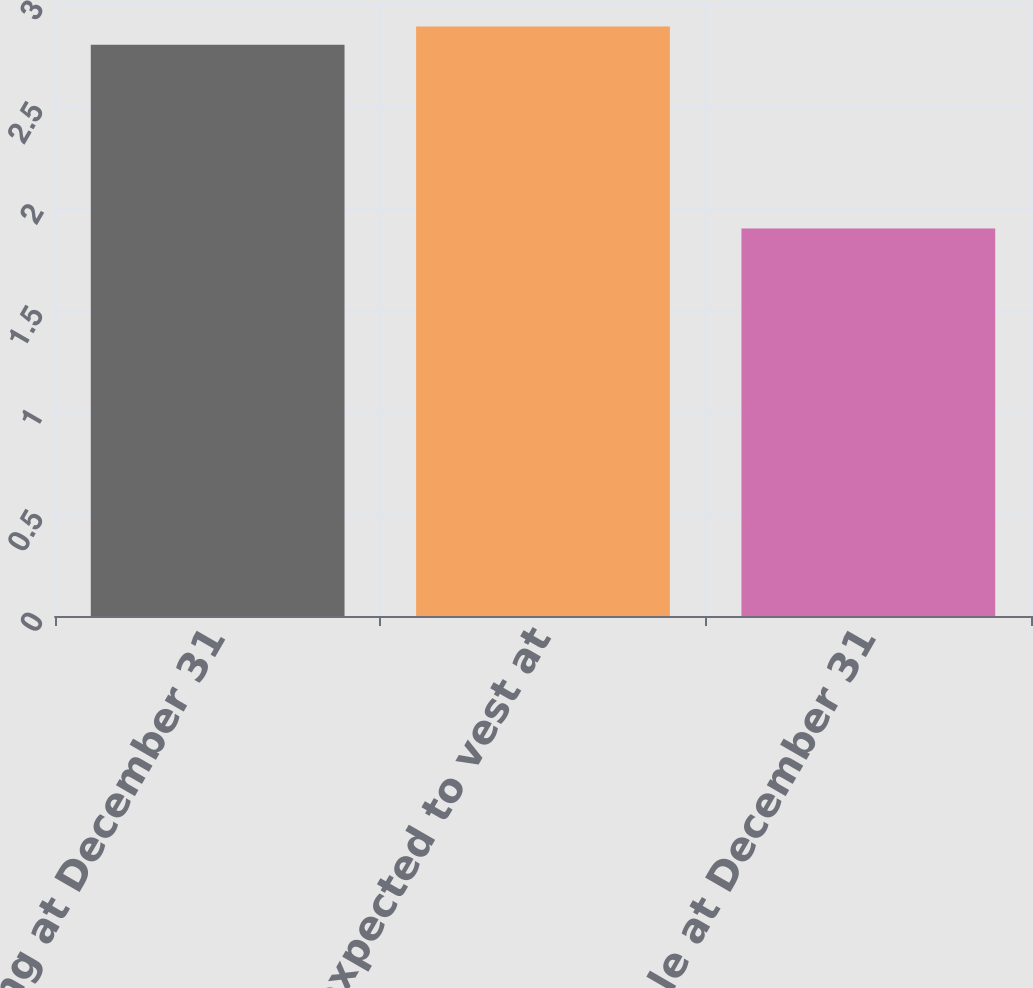Convert chart. <chart><loc_0><loc_0><loc_500><loc_500><bar_chart><fcel>Outstanding at December 31<fcel>Vested and expected to vest at<fcel>Exercisable at December 31<nl><fcel>2.8<fcel>2.89<fcel>1.9<nl></chart> 